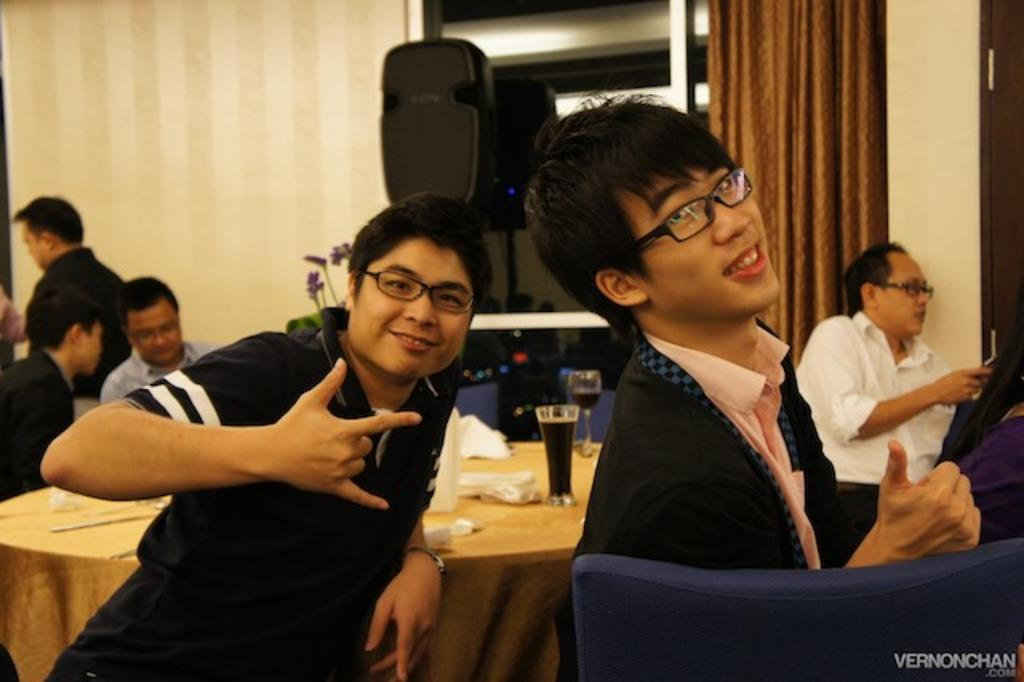How many people are in the image? There are people in the image, but the exact number is not specified. What are the people doing in the image? Some people are standing, and at least one person is sitting. What furniture is present in the image? There are chairs and tables in the image. What objects can be seen on the tables? There are glasses in the image. What items are present for cleaning or personal use? There are tissues in the image. What architectural feature is visible in the image? There is a wall with a glass window in the image. Is there any window treatment present in the image? Yes, there is a curtain associated with the window. How fast is the bridge being built in the image? There is no bridge present in the image, so it is not possible to determine the rate at which it is being built. 